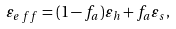<formula> <loc_0><loc_0><loc_500><loc_500>\varepsilon _ { e \, f \, f } = ( 1 - f _ { a } ) \varepsilon _ { h } + f _ { a } \varepsilon _ { s } ,</formula> 